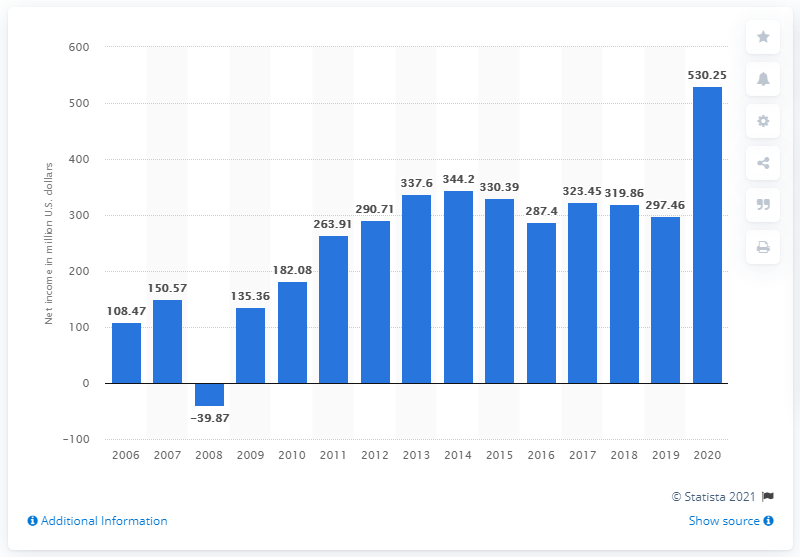Indicate a few pertinent items in this graphic. In the financial year of 2020, the net income of Dick's Sporting Goods was $530.25 million. 